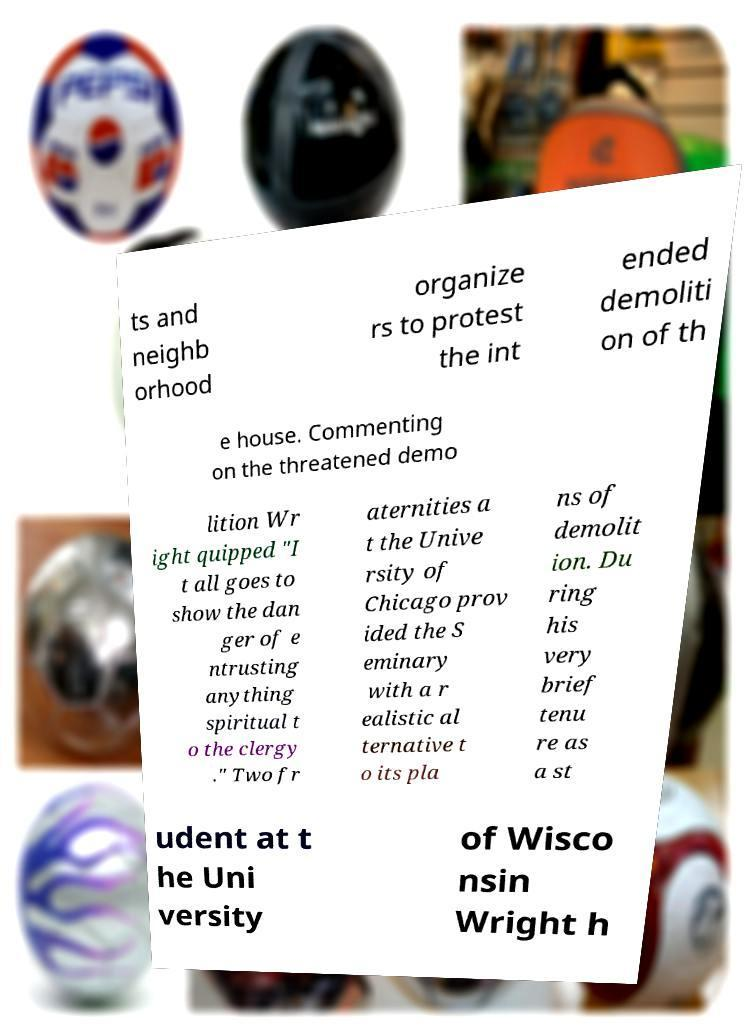There's text embedded in this image that I need extracted. Can you transcribe it verbatim? ts and neighb orhood organize rs to protest the int ended demoliti on of th e house. Commenting on the threatened demo lition Wr ight quipped "I t all goes to show the dan ger of e ntrusting anything spiritual t o the clergy ." Two fr aternities a t the Unive rsity of Chicago prov ided the S eminary with a r ealistic al ternative t o its pla ns of demolit ion. Du ring his very brief tenu re as a st udent at t he Uni versity of Wisco nsin Wright h 